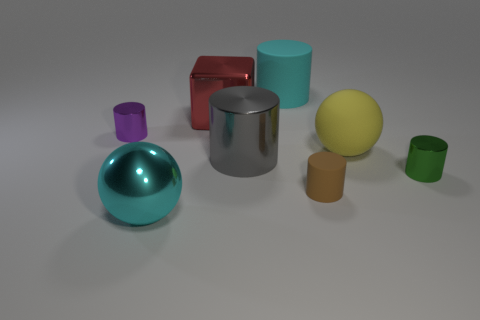What size is the sphere that is in front of the tiny thing that is in front of the tiny metal object in front of the big yellow object?
Your answer should be compact. Large. The large metallic cylinder has what color?
Your answer should be compact. Gray. Is the number of objects to the right of the large block greater than the number of large objects?
Give a very brief answer. No. There is a gray cylinder; what number of big metallic balls are on the right side of it?
Offer a very short reply. 0. There is a large rubber object that is the same color as the metal ball; what shape is it?
Your response must be concise. Cylinder. Are there any tiny objects to the left of the large cyan thing that is behind the large cyan object that is in front of the yellow object?
Offer a very short reply. Yes. Does the purple metallic thing have the same size as the gray shiny cylinder?
Provide a succinct answer. No. Is the number of tiny cylinders in front of the big gray cylinder the same as the number of purple cylinders that are on the right side of the big cyan metallic thing?
Make the answer very short. No. What shape is the cyan thing in front of the tiny brown rubber object?
Your response must be concise. Sphere. There is a yellow thing that is the same size as the red metal object; what is its shape?
Offer a very short reply. Sphere. 